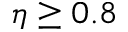<formula> <loc_0><loc_0><loc_500><loc_500>\eta \geq 0 . 8</formula> 